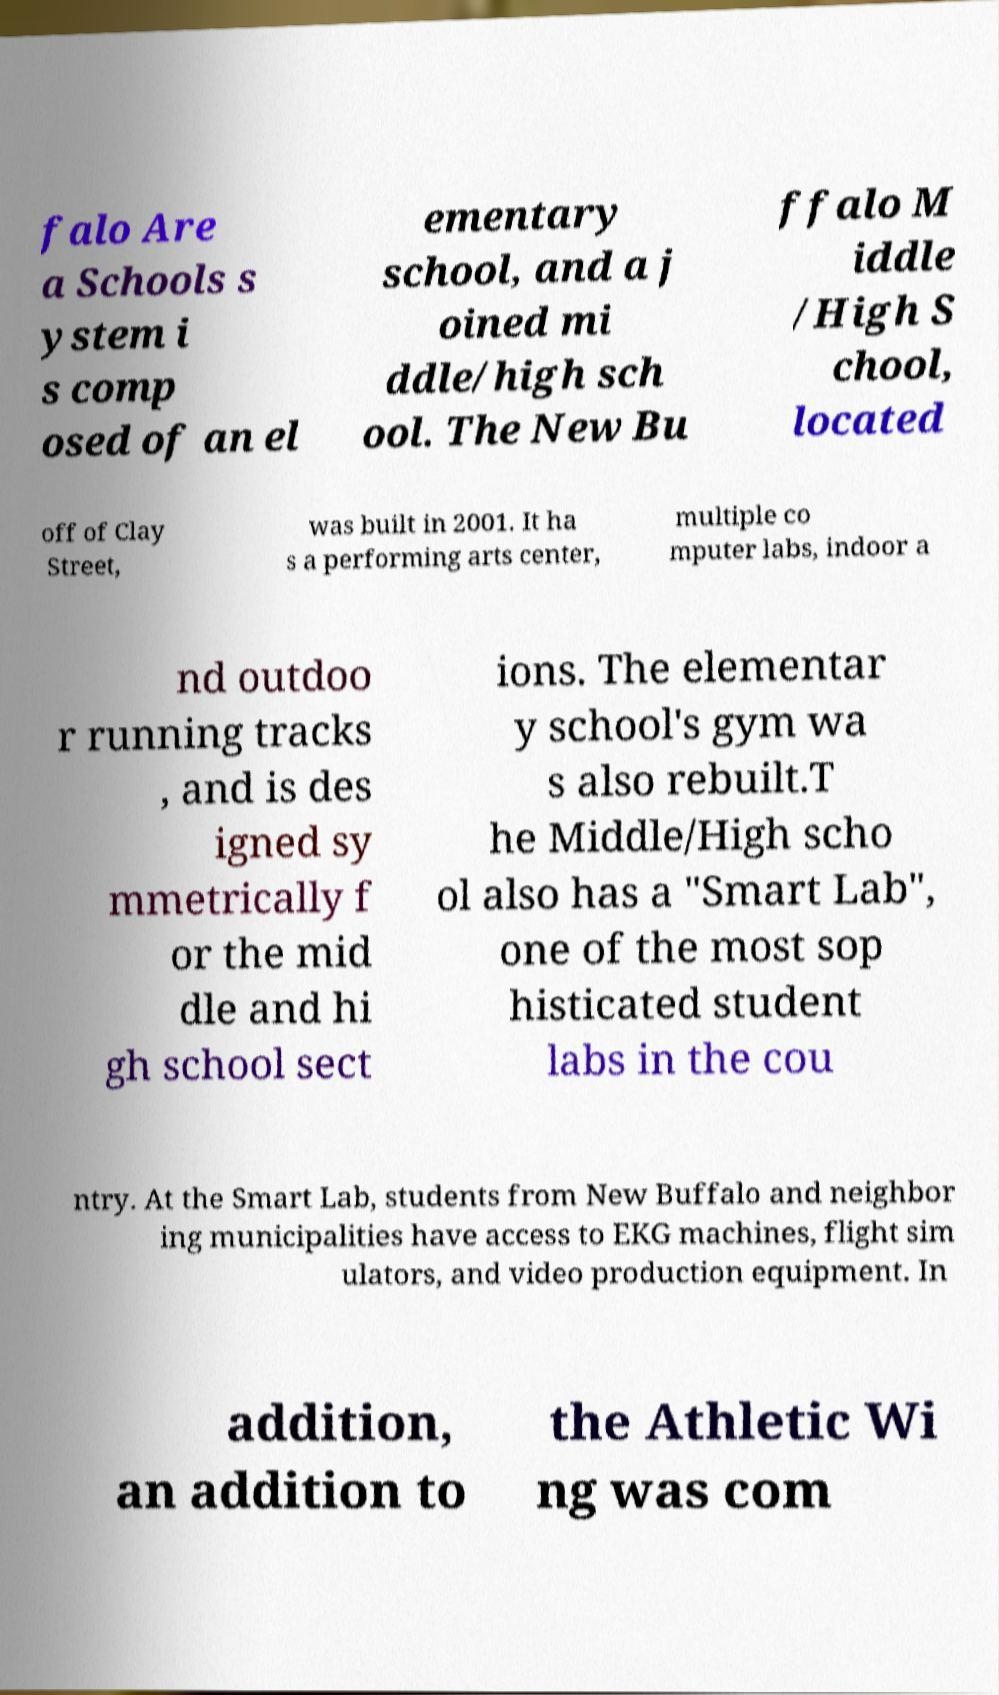Could you extract and type out the text from this image? falo Are a Schools s ystem i s comp osed of an el ementary school, and a j oined mi ddle/high sch ool. The New Bu ffalo M iddle /High S chool, located off of Clay Street, was built in 2001. It ha s a performing arts center, multiple co mputer labs, indoor a nd outdoo r running tracks , and is des igned sy mmetrically f or the mid dle and hi gh school sect ions. The elementar y school's gym wa s also rebuilt.T he Middle/High scho ol also has a "Smart Lab", one of the most sop histicated student labs in the cou ntry. At the Smart Lab, students from New Buffalo and neighbor ing municipalities have access to EKG machines, flight sim ulators, and video production equipment. In addition, an addition to the Athletic Wi ng was com 